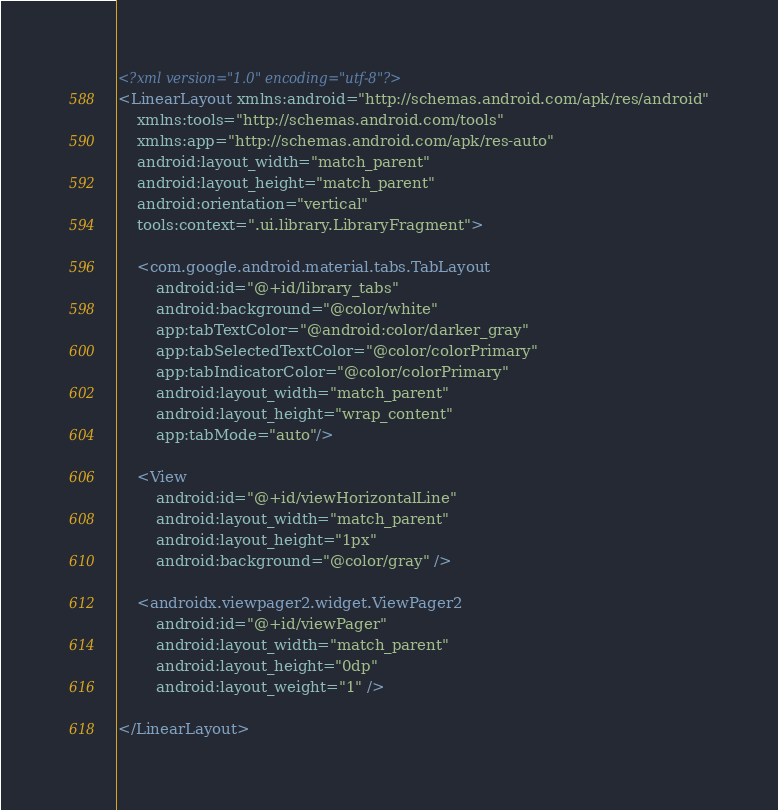<code> <loc_0><loc_0><loc_500><loc_500><_XML_><?xml version="1.0" encoding="utf-8"?>
<LinearLayout xmlns:android="http://schemas.android.com/apk/res/android"
    xmlns:tools="http://schemas.android.com/tools"
    xmlns:app="http://schemas.android.com/apk/res-auto"
    android:layout_width="match_parent"
    android:layout_height="match_parent"
    android:orientation="vertical"
    tools:context=".ui.library.LibraryFragment">

    <com.google.android.material.tabs.TabLayout
        android:id="@+id/library_tabs"
        android:background="@color/white"
        app:tabTextColor="@android:color/darker_gray"
        app:tabSelectedTextColor="@color/colorPrimary"
        app:tabIndicatorColor="@color/colorPrimary"
        android:layout_width="match_parent"
        android:layout_height="wrap_content"
        app:tabMode="auto"/>

    <View
        android:id="@+id/viewHorizontalLine"
        android:layout_width="match_parent"
        android:layout_height="1px"
        android:background="@color/gray" />

    <androidx.viewpager2.widget.ViewPager2
        android:id="@+id/viewPager"
        android:layout_width="match_parent"
        android:layout_height="0dp"
        android:layout_weight="1" />

</LinearLayout></code> 